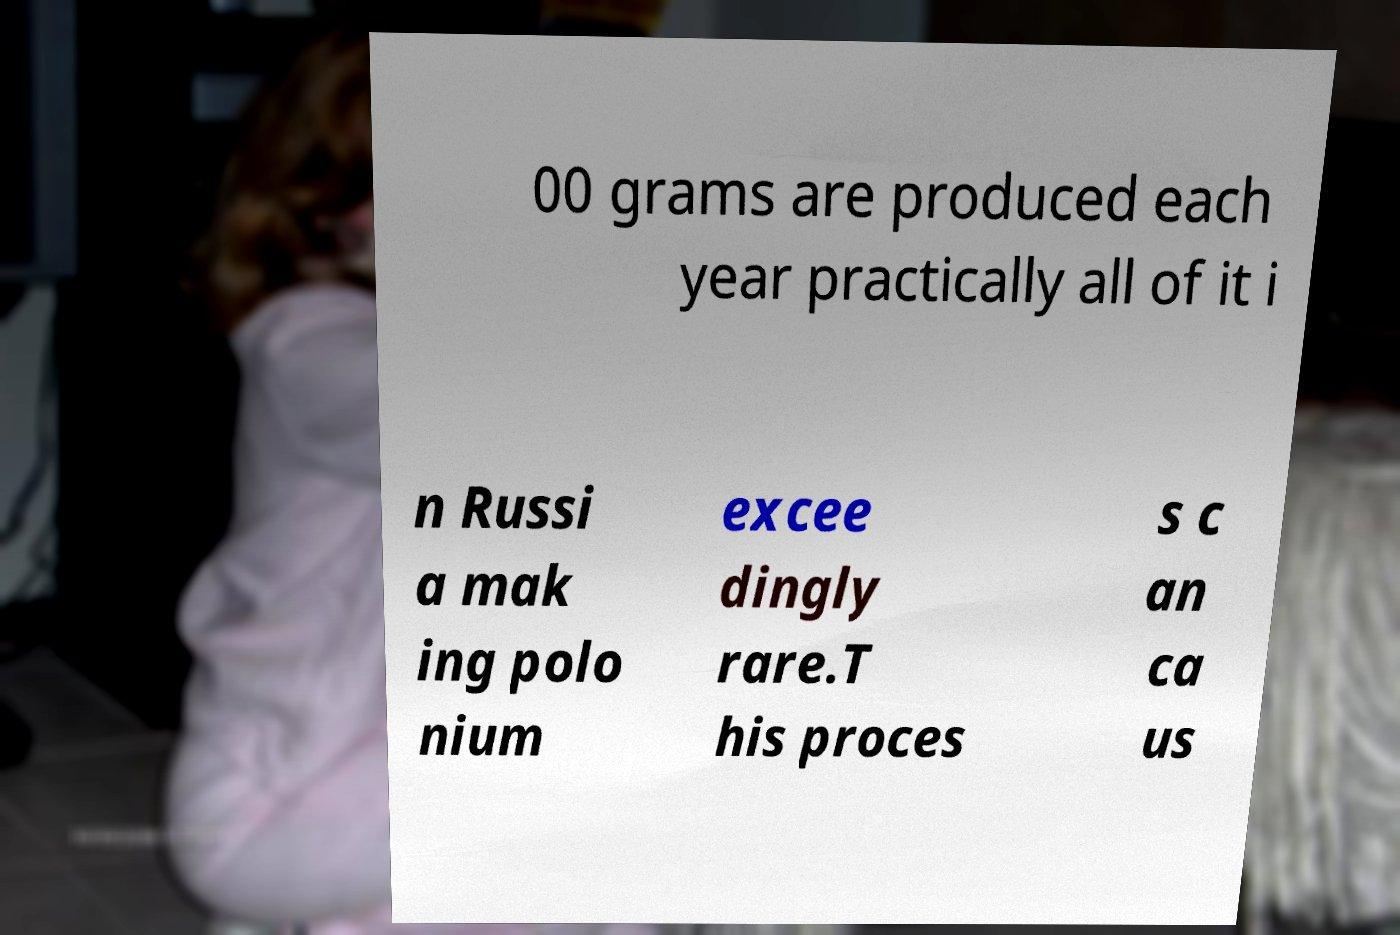Can you accurately transcribe the text from the provided image for me? 00 grams are produced each year practically all of it i n Russi a mak ing polo nium excee dingly rare.T his proces s c an ca us 